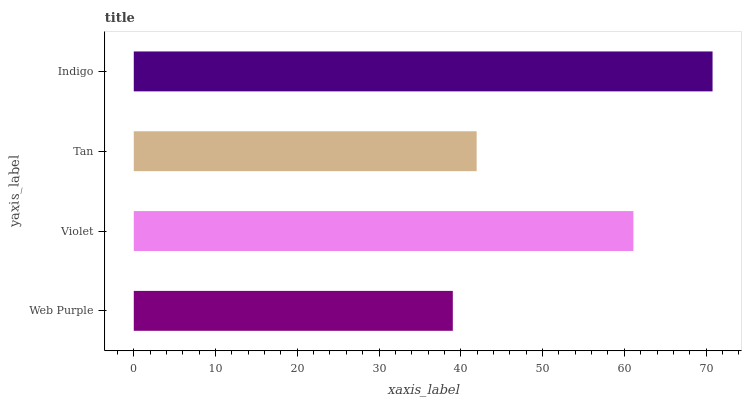Is Web Purple the minimum?
Answer yes or no. Yes. Is Indigo the maximum?
Answer yes or no. Yes. Is Violet the minimum?
Answer yes or no. No. Is Violet the maximum?
Answer yes or no. No. Is Violet greater than Web Purple?
Answer yes or no. Yes. Is Web Purple less than Violet?
Answer yes or no. Yes. Is Web Purple greater than Violet?
Answer yes or no. No. Is Violet less than Web Purple?
Answer yes or no. No. Is Violet the high median?
Answer yes or no. Yes. Is Tan the low median?
Answer yes or no. Yes. Is Web Purple the high median?
Answer yes or no. No. Is Indigo the low median?
Answer yes or no. No. 